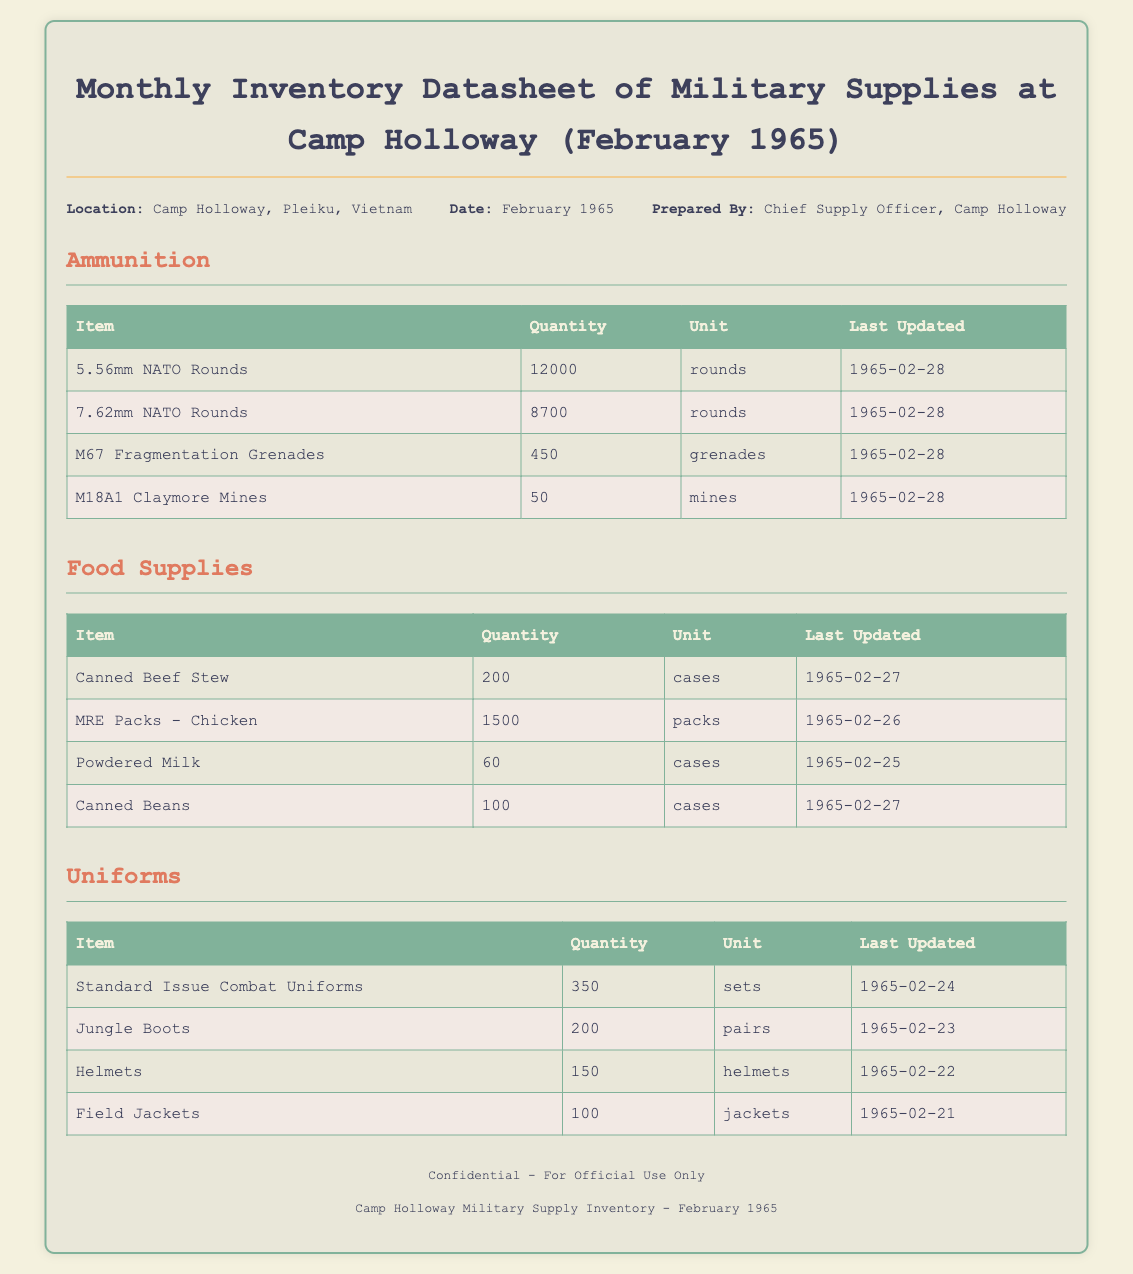What is the total quantity of 5.56mm NATO Rounds? The total quantity of 5.56mm NATO Rounds listed in the datasheet is 12000.
Answer: 12000 What type of helmets are listed in the uniforms section? The type of helmets listed is "Helmets," which refers to the protective gear for soldiers.
Answer: Helmets When was the last update for MRE Packs - Chicken? The last update for MRE Packs - Chicken is provided as "1965-02-26."
Answer: 1965-02-26 How many pairs of Jungle Boots are available? The document states there are 200 pairs of Jungle Boots available.
Answer: 200 What is the quantity of Canned Beef Stew in cases? The datasheet indicates there are 200 cases of Canned Beef Stew.
Answer: 200 Which department prepared the inventory datasheet? The datasheet was prepared by the "Chief Supply Officer, Camp Holloway."
Answer: Chief Supply Officer, Camp Holloway How many types of food supplies are listed in the document? The food supplies section lists four types: Canned Beef Stew, MRE Packs - Chicken, Powdered Milk, and Canned Beans.
Answer: 4 What is the last updated date for Standard Issue Combat Uniforms? The last updated date for Standard Issue Combat Uniforms is "1965-02-24."
Answer: 1965-02-24 How many M67 Fragmentation Grenades are available? According to the inventory, there are 450 M67 Fragmentation Grenades available.
Answer: 450 